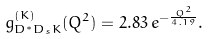Convert formula to latex. <formula><loc_0><loc_0><loc_500><loc_500>g _ { D ^ { * } D _ { s } K } ^ { ( K ) } ( Q ^ { 2 } ) = 2 . 8 3 \, e ^ { - \frac { Q ^ { 2 } } { 4 . 1 9 } } .</formula> 